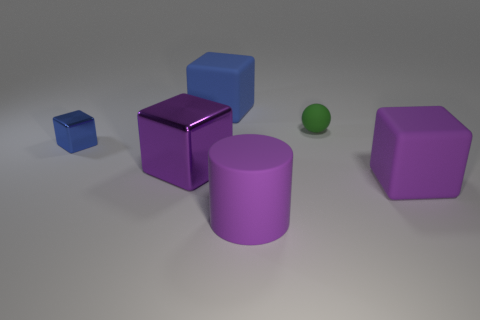Subtract all blue spheres. Subtract all green blocks. How many spheres are left? 1 Add 2 purple objects. How many objects exist? 8 Subtract all cubes. How many objects are left? 2 Subtract all tiny red cylinders. Subtract all tiny blocks. How many objects are left? 5 Add 1 matte cylinders. How many matte cylinders are left? 2 Add 5 large brown rubber cylinders. How many large brown rubber cylinders exist? 5 Subtract 0 purple spheres. How many objects are left? 6 